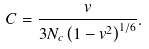<formula> <loc_0><loc_0><loc_500><loc_500>C = \frac { v } { 3 N _ { c } \left ( 1 - v ^ { 2 } \right ) ^ { 1 / 6 } } .</formula> 